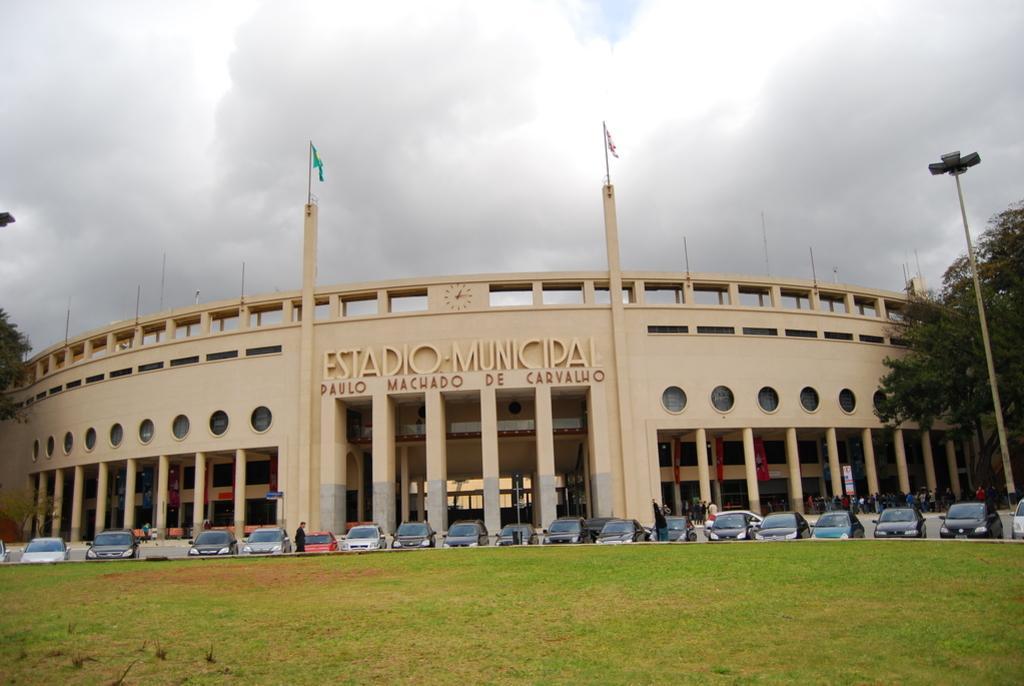Could you give a brief overview of what you see in this image? In this image in the front there's grass on the ground. In the center there are cars and there are persons. In the background there is building and there are trees, on the top of the building there are flags and the sky is cloudy. 